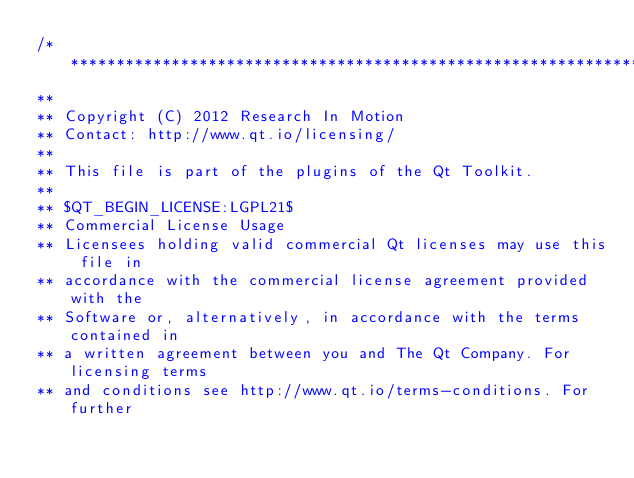Convert code to text. <code><loc_0><loc_0><loc_500><loc_500><_C_>/****************************************************************************
**
** Copyright (C) 2012 Research In Motion
** Contact: http://www.qt.io/licensing/
**
** This file is part of the plugins of the Qt Toolkit.
**
** $QT_BEGIN_LICENSE:LGPL21$
** Commercial License Usage
** Licensees holding valid commercial Qt licenses may use this file in
** accordance with the commercial license agreement provided with the
** Software or, alternatively, in accordance with the terms contained in
** a written agreement between you and The Qt Company. For licensing terms
** and conditions see http://www.qt.io/terms-conditions. For further</code> 